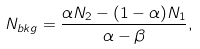Convert formula to latex. <formula><loc_0><loc_0><loc_500><loc_500>N _ { b k g } = \frac { \alpha N _ { 2 } - ( 1 - \alpha ) N _ { 1 } } { \alpha - \beta } ,</formula> 